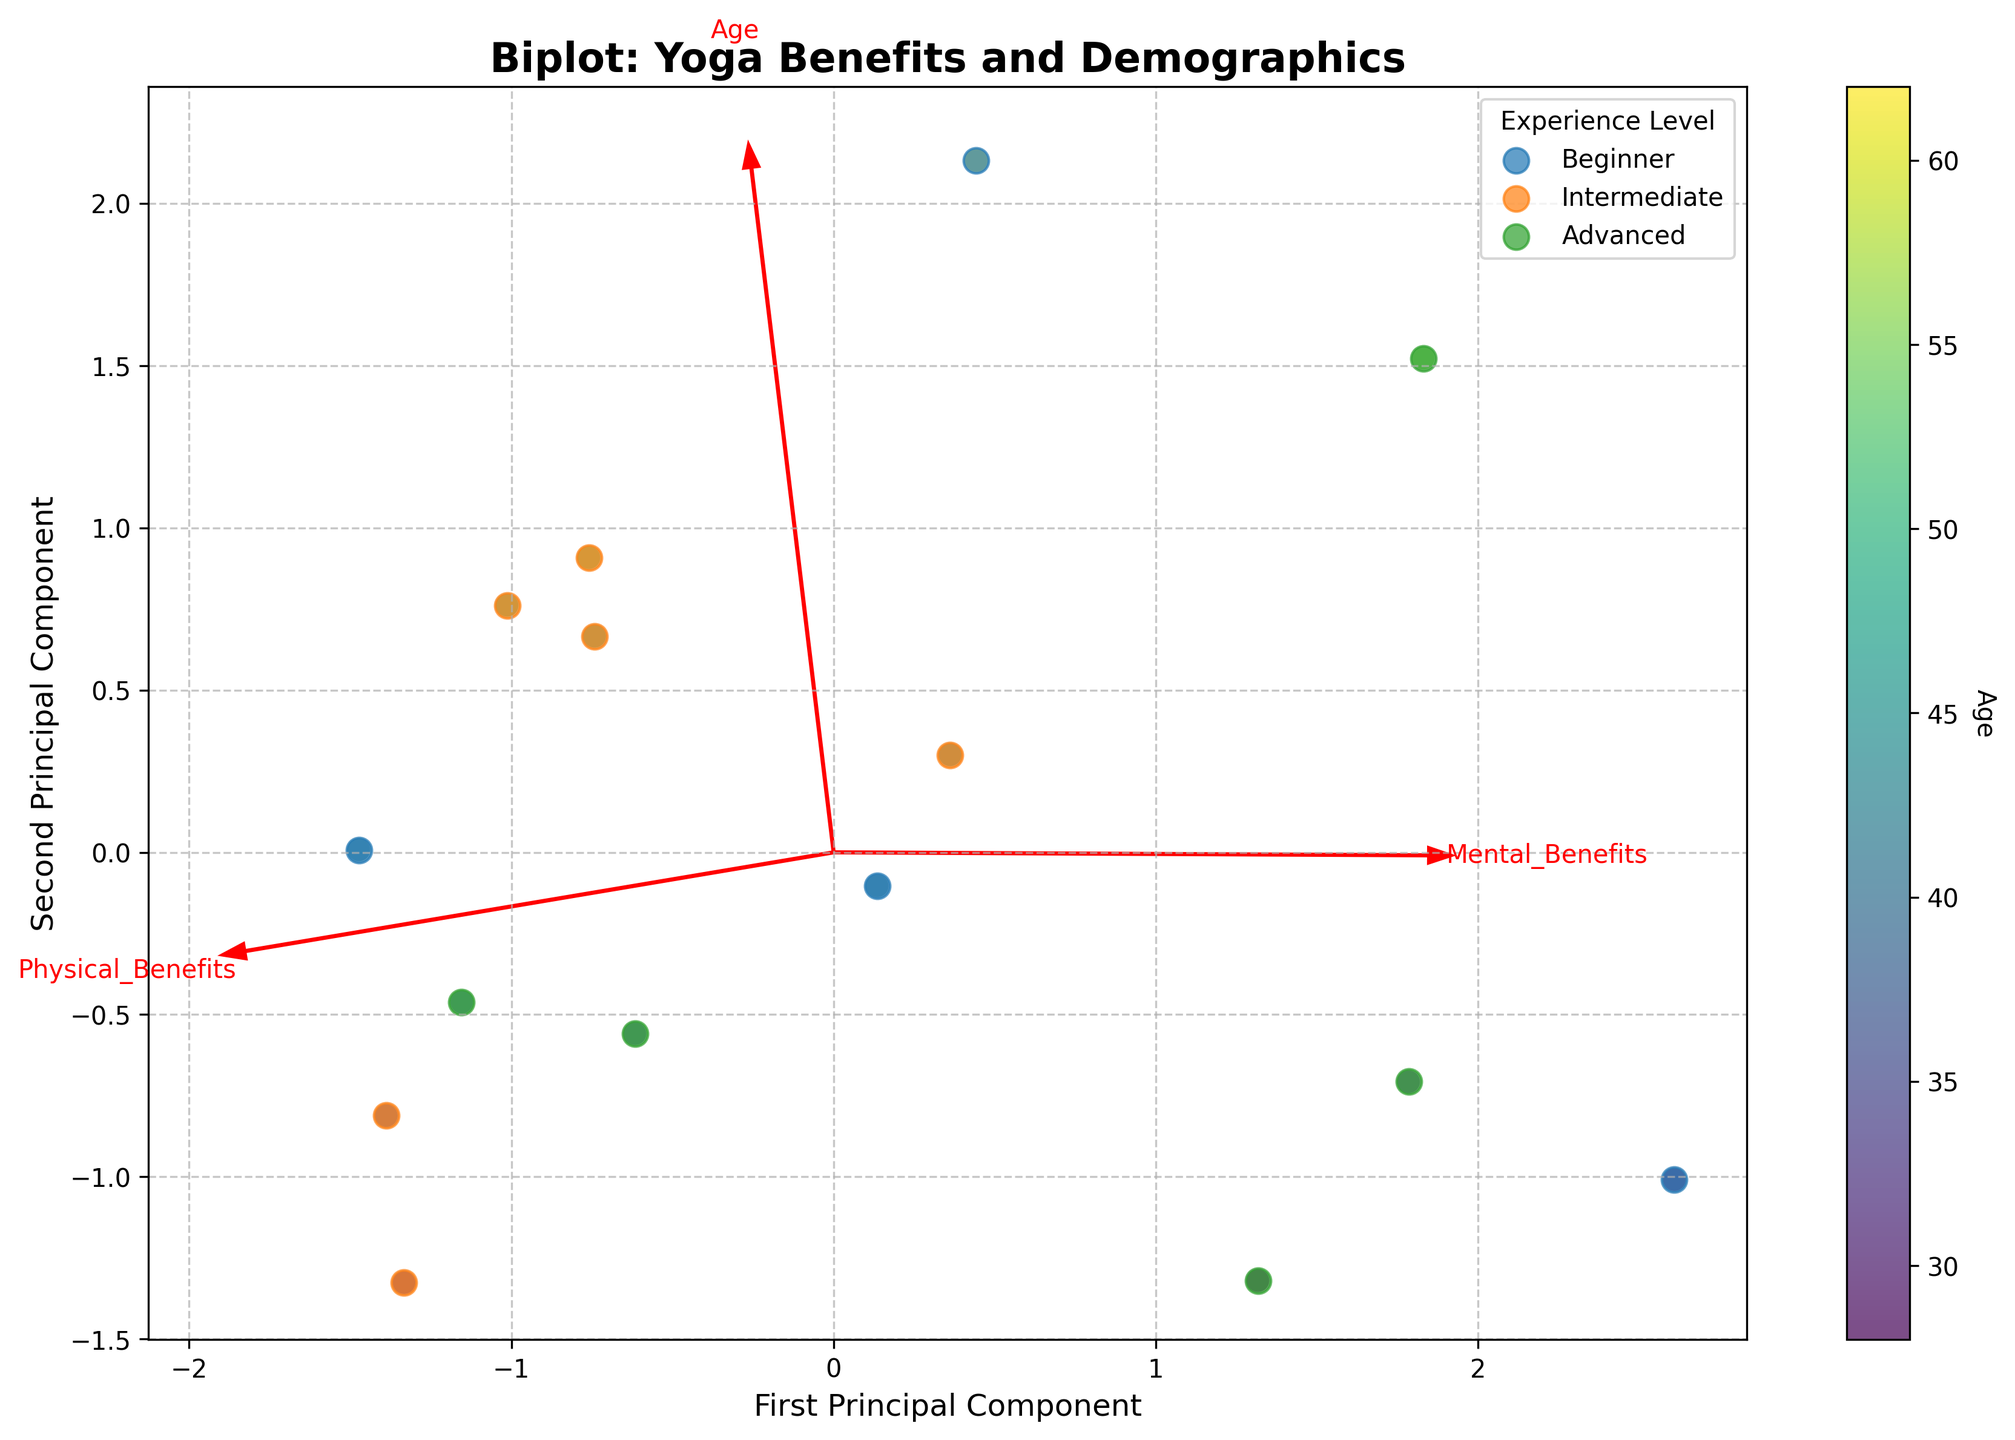How many different experience levels are represented in the biplot? By looking at the legend in the figure, we can identify the different experience levels. The legend shows three levels: 'Beginner', 'Intermediate', and 'Advanced'.
Answer: Three Which principal component captures more variance? The principal component that captures more variance is usually indicated by the component with the longest feature vectors. By comparing the feature vector lengths along both axes, it appears that the First Principal Component (x-axis) captures more variance as it stretches farther.
Answer: First Principal Component Do older participants report more physical or mental benefits? By observing the color gradient (representing Age) in correlation with data points, we can see that older participants (darker colors) appear at intermediate levels in both principal components, indicating a balanced report of physical and mental benefits rather than a dominant benefit in one area.
Answer: Balanced Which benefit has the highest impact on the first principal component? By examining the direction and length of the red arrows, we can identify that 'Improved Flexibility' has the longest arrow projection along the first principal component (x-axis), indicating it has the highest impact on this component.
Answer: Improved Flexibility What does the color of data points represent? The color of the data points changes according to a gradient scale displayed by the color bar. This color bar title indicates that the colors represent 'Age'.
Answer: Age Which feature vectors point in roughly similar directions? By observing the arrows (feature vectors) in the figure, 'Increased Strength' and 'Enhanced Balance' point in roughly similar directions, indicating they have similar contributions to the principal components.
Answer: Increased Strength and Enhanced Balance Are beginners more associated with mental or physical benefits? By looking at the clusters of data points for beginners and their positions relative to the red arrows, beginners seem to be closer to vectors pointing towards mental benefits like 'Stress Reduction' and 'Reduced Anxiety'.
Answer: Mental Benefits How is 'Better Sleep Quality' represented in relation to the principal components? The arrow for 'Better Sleep Quality' stretches more towards the positive end of the second principal component (y-axis), indicating it has a significant contribution to the mental benefits dimension.
Answer: Second Principal Component What is the relationship between age and the second principal component? By examining the color gradient along the y-axis (second principal component), older participants (darker colors) seem to align more with higher values of the second principal component, suggesting a positive relationship between age and this component.
Answer: Positive Relationship 